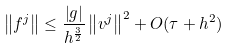<formula> <loc_0><loc_0><loc_500><loc_500>\left \| f ^ { j } \right \| \leq \frac { \left | g \right | } { h ^ { \frac { 3 } { 2 } } } \left \| v ^ { j } \right \| ^ { 2 } + O ( \tau + h ^ { 2 } )</formula> 